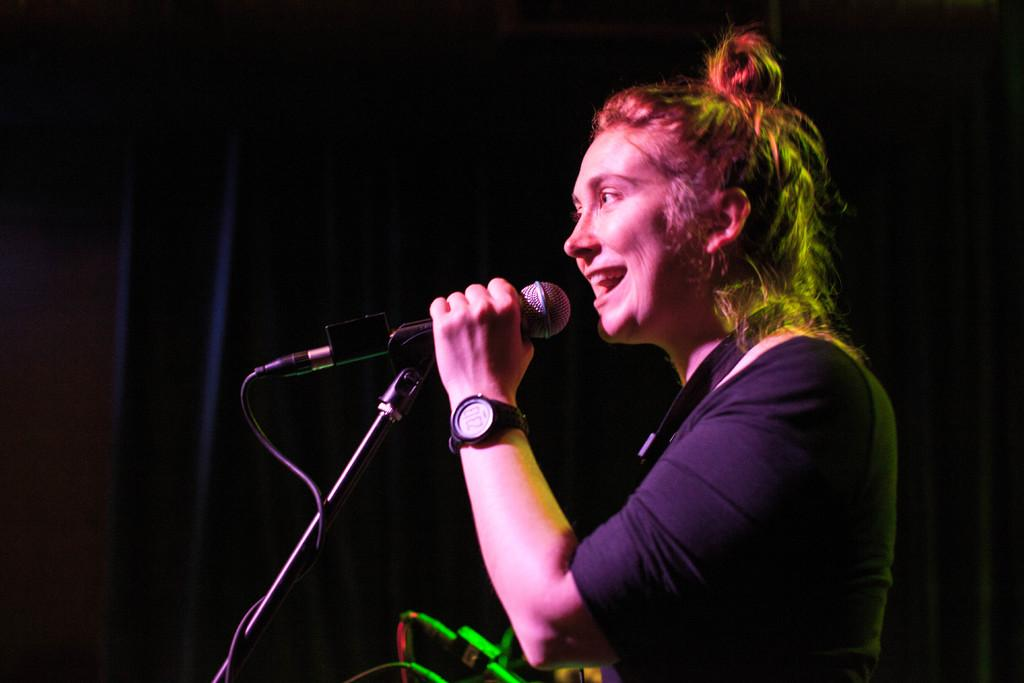Who is the main subject in the image? There is a woman in the image. What is the woman holding in the image? The woman is holding a microphone. What accessory is the woman wearing in the image? The woman is wearing a watch. What can be seen in the background of the image? There is a black curtain in the background of the image. What else is visible at the bottom of the image? There are wires visible at the bottom of the image. What type of list can be seen in the woman's hand in the image? There is no list visible in the woman's hand in the image. 